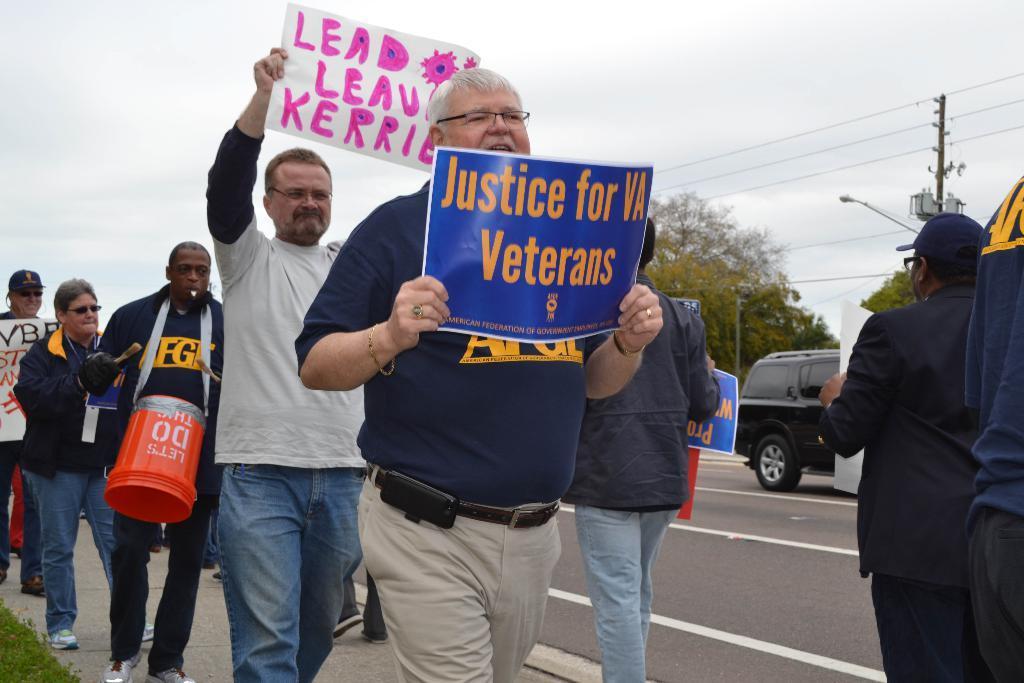In one or two sentences, can you explain what this image depicts? Here we can see few persons and they are holding posters with their hands. There is a car on the road. In the background we can see trees, pole, and sky. 